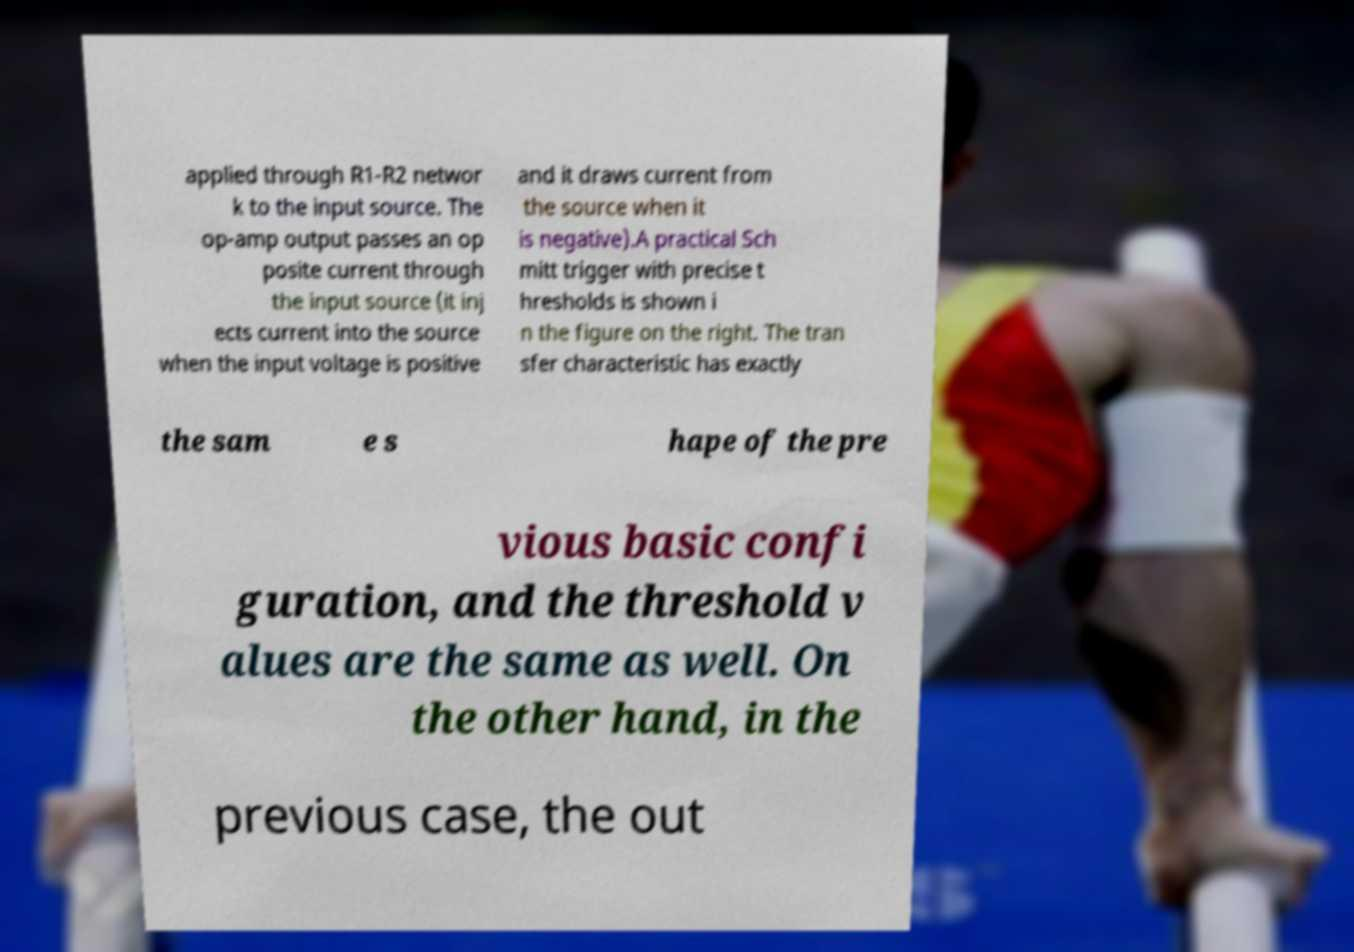There's text embedded in this image that I need extracted. Can you transcribe it verbatim? applied through R1-R2 networ k to the input source. The op-amp output passes an op posite current through the input source (it inj ects current into the source when the input voltage is positive and it draws current from the source when it is negative).A practical Sch mitt trigger with precise t hresholds is shown i n the figure on the right. The tran sfer characteristic has exactly the sam e s hape of the pre vious basic confi guration, and the threshold v alues are the same as well. On the other hand, in the previous case, the out 